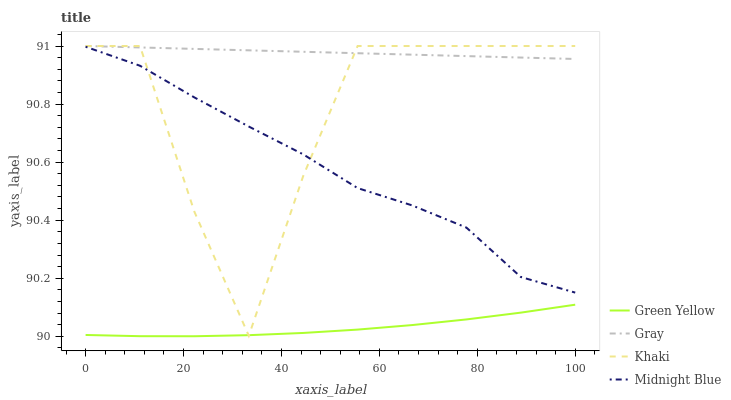Does Green Yellow have the minimum area under the curve?
Answer yes or no. Yes. Does Gray have the maximum area under the curve?
Answer yes or no. Yes. Does Khaki have the minimum area under the curve?
Answer yes or no. No. Does Khaki have the maximum area under the curve?
Answer yes or no. No. Is Gray the smoothest?
Answer yes or no. Yes. Is Khaki the roughest?
Answer yes or no. Yes. Is Green Yellow the smoothest?
Answer yes or no. No. Is Green Yellow the roughest?
Answer yes or no. No. Does Green Yellow have the lowest value?
Answer yes or no. Yes. Does Khaki have the lowest value?
Answer yes or no. No. Does Khaki have the highest value?
Answer yes or no. Yes. Does Green Yellow have the highest value?
Answer yes or no. No. Is Green Yellow less than Gray?
Answer yes or no. Yes. Is Gray greater than Green Yellow?
Answer yes or no. Yes. Does Green Yellow intersect Khaki?
Answer yes or no. Yes. Is Green Yellow less than Khaki?
Answer yes or no. No. Is Green Yellow greater than Khaki?
Answer yes or no. No. Does Green Yellow intersect Gray?
Answer yes or no. No. 